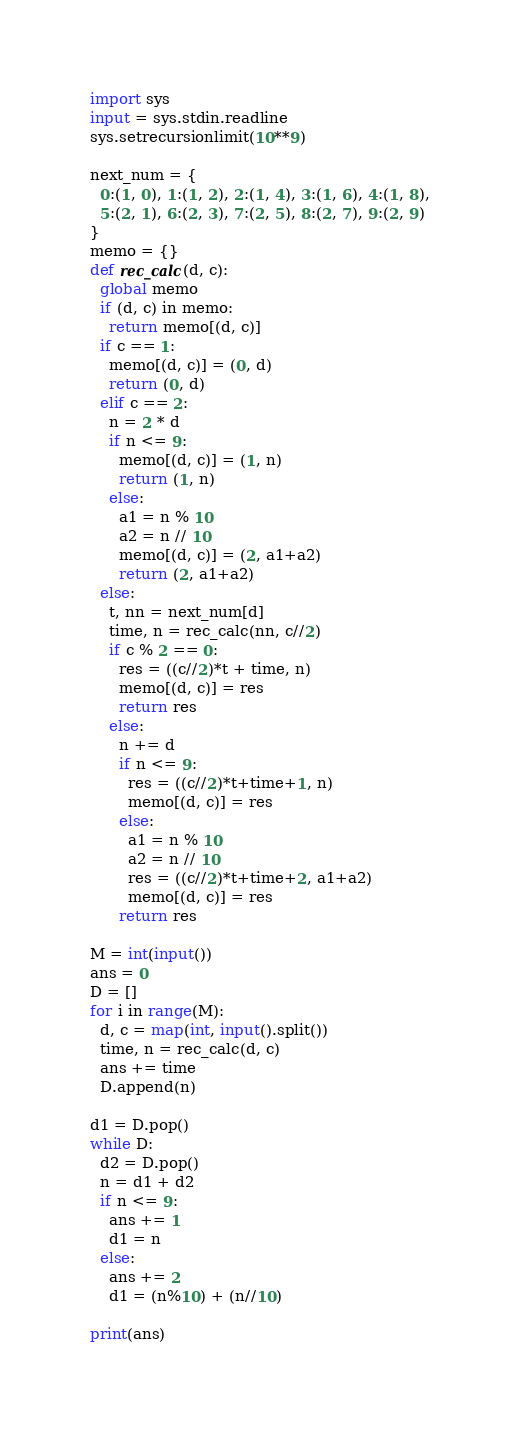<code> <loc_0><loc_0><loc_500><loc_500><_Python_>import sys
input = sys.stdin.readline
sys.setrecursionlimit(10**9)

next_num = {
  0:(1, 0), 1:(1, 2), 2:(1, 4), 3:(1, 6), 4:(1, 8),
  5:(2, 1), 6:(2, 3), 7:(2, 5), 8:(2, 7), 9:(2, 9)
}
memo = {}
def rec_calc(d, c):
  global memo
  if (d, c) in memo:
    return memo[(d, c)]
  if c == 1:
    memo[(d, c)] = (0, d)
    return (0, d)
  elif c == 2:
    n = 2 * d
    if n <= 9:
      memo[(d, c)] = (1, n)
      return (1, n)
    else:
      a1 = n % 10
      a2 = n // 10
      memo[(d, c)] = (2, a1+a2)
      return (2, a1+a2)
  else:
    t, nn = next_num[d]
    time, n = rec_calc(nn, c//2)
    if c % 2 == 0:
      res = ((c//2)*t + time, n)
      memo[(d, c)] = res
      return res
    else:
      n += d
      if n <= 9:
        res = ((c//2)*t+time+1, n)
        memo[(d, c)] = res
      else:
        a1 = n % 10
        a2 = n // 10
        res = ((c//2)*t+time+2, a1+a2)
        memo[(d, c)] = res
      return res

M = int(input())
ans = 0
D = []
for i in range(M):
  d, c = map(int, input().split())
  time, n = rec_calc(d, c)
  ans += time
  D.append(n)

d1 = D.pop()
while D:
  d2 = D.pop()
  n = d1 + d2
  if n <= 9:
    ans += 1
    d1 = n
  else:
    ans += 2
    d1 = (n%10) + (n//10)

print(ans)
</code> 